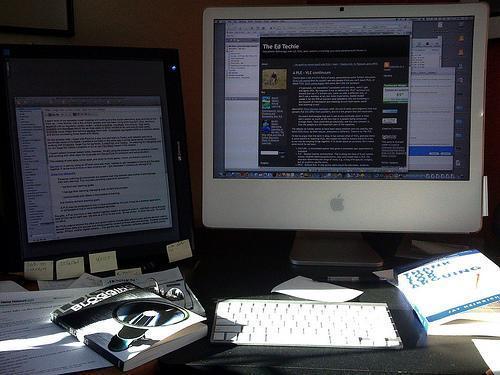How many people are typing computer?
Give a very brief answer. 0. 